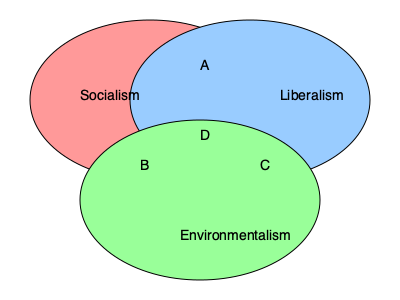In the Venn diagram above, which region represents ideologies that combine elements of socialism, liberalism, and environmentalism? To answer this question, we need to analyze the Venn diagram and understand the overlapping regions:

1. The diagram consists of three circles representing Socialism, Liberalism, and Environmentalism.

2. Each circle overlap creates regions that represent combinations of two ideologies:
   - Socialism and Liberalism overlap in region A
   - Socialism and Environmentalism overlap in region B
   - Liberalism and Environmentalism overlap in region C

3. The center region, where all three circles intersect, is labeled D.

4. Region D represents the area where all three ideologies overlap, combining elements of Socialism, Liberalism, and Environmentalism.

5. This intersection (D) is often associated with ideologies like eco-socialism or green liberalism, which attempt to reconcile environmental concerns with both socialist and liberal principles.

Therefore, the region that represents ideologies combining elements of socialism, liberalism, and environmentalism is region D, the central area where all three circles intersect.
Answer: D 